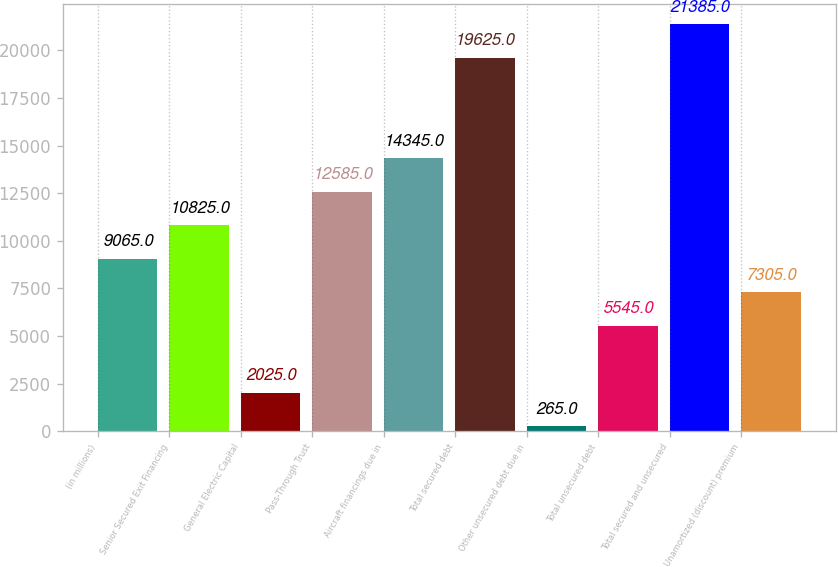Convert chart to OTSL. <chart><loc_0><loc_0><loc_500><loc_500><bar_chart><fcel>(in millions)<fcel>Senior Secured Exit Financing<fcel>General Electric Capital<fcel>Pass-Through Trust<fcel>Aircraft financings due in<fcel>Total secured debt<fcel>Other unsecured debt due in<fcel>Total unsecured debt<fcel>Total secured and unsecured<fcel>Unamortized (discount) premium<nl><fcel>9065<fcel>10825<fcel>2025<fcel>12585<fcel>14345<fcel>19625<fcel>265<fcel>5545<fcel>21385<fcel>7305<nl></chart> 